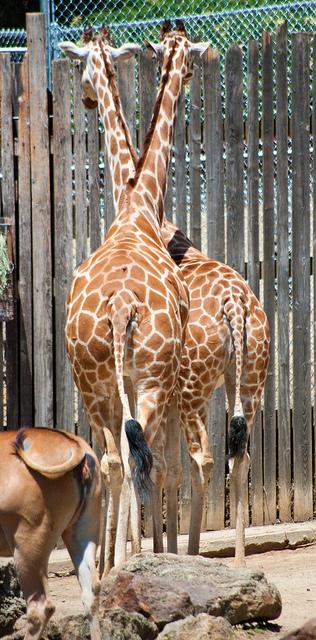The head on the left belongs to which giraffe?
Short answer required. Right. Is there another animal visible that isn't a giraffe?
Give a very brief answer. Yes. Are all of the giraffes pictured adults?
Write a very short answer. Yes. 